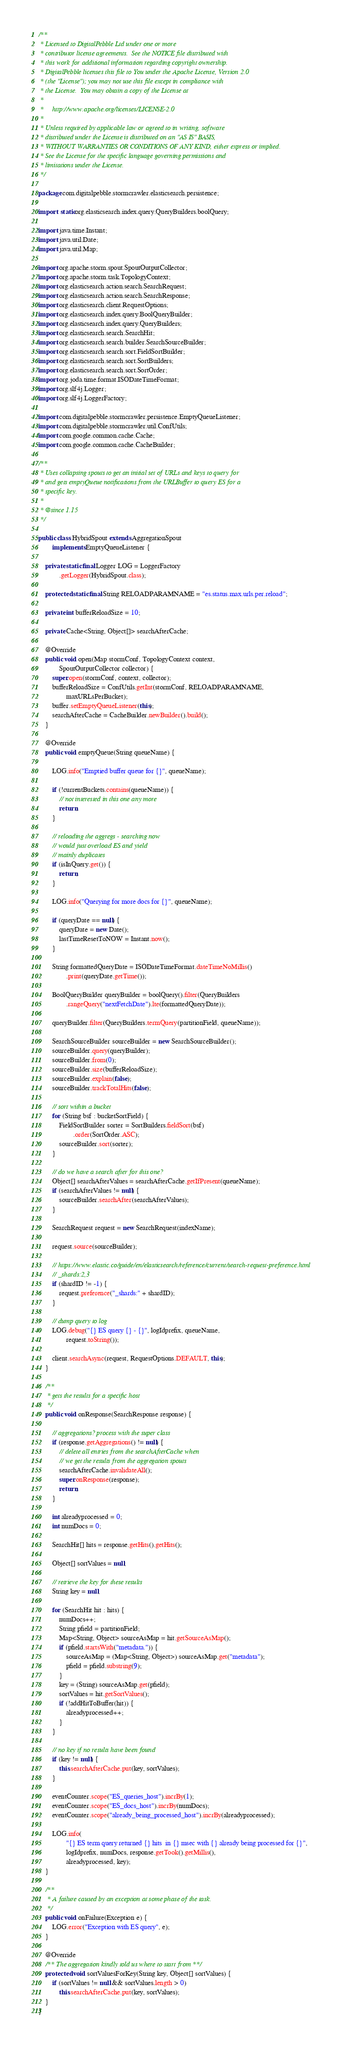Convert code to text. <code><loc_0><loc_0><loc_500><loc_500><_Java_>/**
 * Licensed to DigitalPebble Ltd under one or more
 * contributor license agreements.  See the NOTICE file distributed with
 * this work for additional information regarding copyright ownership.
 * DigitalPebble licenses this file to You under the Apache License, Version 2.0
 * (the "License"); you may not use this file except in compliance with
 * the License.  You may obtain a copy of the License at
 *
 *     http://www.apache.org/licenses/LICENSE-2.0
 *
 * Unless required by applicable law or agreed to in writing, software
 * distributed under the License is distributed on an "AS IS" BASIS,
 * WITHOUT WARRANTIES OR CONDITIONS OF ANY KIND, either express or implied.
 * See the License for the specific language governing permissions and
 * limitations under the License.
 */

package com.digitalpebble.stormcrawler.elasticsearch.persistence;

import static org.elasticsearch.index.query.QueryBuilders.boolQuery;

import java.time.Instant;
import java.util.Date;
import java.util.Map;

import org.apache.storm.spout.SpoutOutputCollector;
import org.apache.storm.task.TopologyContext;
import org.elasticsearch.action.search.SearchRequest;
import org.elasticsearch.action.search.SearchResponse;
import org.elasticsearch.client.RequestOptions;
import org.elasticsearch.index.query.BoolQueryBuilder;
import org.elasticsearch.index.query.QueryBuilders;
import org.elasticsearch.search.SearchHit;
import org.elasticsearch.search.builder.SearchSourceBuilder;
import org.elasticsearch.search.sort.FieldSortBuilder;
import org.elasticsearch.search.sort.SortBuilders;
import org.elasticsearch.search.sort.SortOrder;
import org.joda.time.format.ISODateTimeFormat;
import org.slf4j.Logger;
import org.slf4j.LoggerFactory;

import com.digitalpebble.stormcrawler.persistence.EmptyQueueListener;
import com.digitalpebble.stormcrawler.util.ConfUtils;
import com.google.common.cache.Cache;
import com.google.common.cache.CacheBuilder;

/**
 * Uses collapsing spouts to get an initial set of URLs and keys to query for
 * and gets emptyQueue notifications from the URLBuffer to query ES for a
 * specific key.
 * 
 * @since 1.15
 */

public class HybridSpout extends AggregationSpout
        implements EmptyQueueListener {

    private static final Logger LOG = LoggerFactory
            .getLogger(HybridSpout.class);

    protected static final String RELOADPARAMNAME = "es.status.max.urls.per.reload";

    private int bufferReloadSize = 10;

    private Cache<String, Object[]> searchAfterCache;

    @Override
    public void open(Map stormConf, TopologyContext context,
            SpoutOutputCollector collector) {
        super.open(stormConf, context, collector);
        bufferReloadSize = ConfUtils.getInt(stormConf, RELOADPARAMNAME,
                maxURLsPerBucket);
        buffer.setEmptyQueueListener(this);
        searchAfterCache = CacheBuilder.newBuilder().build();
    }

    @Override
    public void emptyQueue(String queueName) {

        LOG.info("Emptied buffer queue for {}", queueName);

        if (!currentBuckets.contains(queueName)) {
            // not interested in this one any more
            return;
        }
        
        // reloading the aggregs - searching now
        // would just overload ES and yield
        // mainly duplicates
        if (isInQuery.get()) {
            return;
        }

        LOG.info("Querying for more docs for {}", queueName);

        if (queryDate == null) {
            queryDate = new Date();
            lastTimeResetToNOW = Instant.now();
        }

        String formattedQueryDate = ISODateTimeFormat.dateTimeNoMillis()
                .print(queryDate.getTime());

        BoolQueryBuilder queryBuilder = boolQuery().filter(QueryBuilders
                .rangeQuery("nextFetchDate").lte(formattedQueryDate));

        queryBuilder.filter(QueryBuilders.termQuery(partitionField, queueName));

        SearchSourceBuilder sourceBuilder = new SearchSourceBuilder();
        sourceBuilder.query(queryBuilder);
        sourceBuilder.from(0);
        sourceBuilder.size(bufferReloadSize);
        sourceBuilder.explain(false);
        sourceBuilder.trackTotalHits(false);

        // sort within a bucket
        for (String bsf : bucketSortField) {
            FieldSortBuilder sorter = SortBuilders.fieldSort(bsf)
                    .order(SortOrder.ASC);
            sourceBuilder.sort(sorter);
        }

        // do we have a search after for this one?
        Object[] searchAfterValues = searchAfterCache.getIfPresent(queueName);
        if (searchAfterValues != null) {
            sourceBuilder.searchAfter(searchAfterValues);
        }

        SearchRequest request = new SearchRequest(indexName);

        request.source(sourceBuilder);

        // https://www.elastic.co/guide/en/elasticsearch/reference/current/search-request-preference.html
        // _shards:2,3
        if (shardID != -1) {
            request.preference("_shards:" + shardID);
        }

        // dump query to log
        LOG.debug("{} ES query {} - {}", logIdprefix, queueName,
                request.toString());

        client.searchAsync(request, RequestOptions.DEFAULT, this);
    }

    /**
     * gets the results for a specific host
     */
    public void onResponse(SearchResponse response) {

        // aggregations? process with the super class
        if (response.getAggregations() != null) {
            // delete all entries from the searchAfterCache when
            // we get the results from the aggregation spouts
            searchAfterCache.invalidateAll();
            super.onResponse(response);
            return;
        }

        int alreadyprocessed = 0;
        int numDocs = 0;

        SearchHit[] hits = response.getHits().getHits();

        Object[] sortValues = null;

        // retrieve the key for these results
        String key = null;

        for (SearchHit hit : hits) {
            numDocs++;
            String pfield = partitionField;
            Map<String, Object> sourceAsMap = hit.getSourceAsMap();
            if (pfield.startsWith("metadata.")) {
                sourceAsMap = (Map<String, Object>) sourceAsMap.get("metadata");
                pfield = pfield.substring(9);
            }
            key = (String) sourceAsMap.get(pfield);
            sortValues = hit.getSortValues();
            if (!addHitToBuffer(hit)) {
                alreadyprocessed++;
            }
        }

        // no key if no results have been found
        if (key != null) {
            this.searchAfterCache.put(key, sortValues);
        }

        eventCounter.scope("ES_queries_host").incrBy(1);
        eventCounter.scope("ES_docs_host").incrBy(numDocs);
        eventCounter.scope("already_being_processed_host").incrBy(alreadyprocessed);

        LOG.info(
                "{} ES term query returned {} hits  in {} msec with {} already being processed for {}",
                logIdprefix, numDocs, response.getTook().getMillis(),
                alreadyprocessed, key);
    }

    /**
     * A failure caused by an exception at some phase of the task.
     */
    public void onFailure(Exception e) {
        LOG.error("Exception with ES query", e);
    }

    @Override
    /** The aggregation kindly told us where to start from **/
    protected void sortValuesForKey(String key, Object[] sortValues) {
        if (sortValues != null && sortValues.length > 0)
            this.searchAfterCache.put(key, sortValues);
    }
}
</code> 